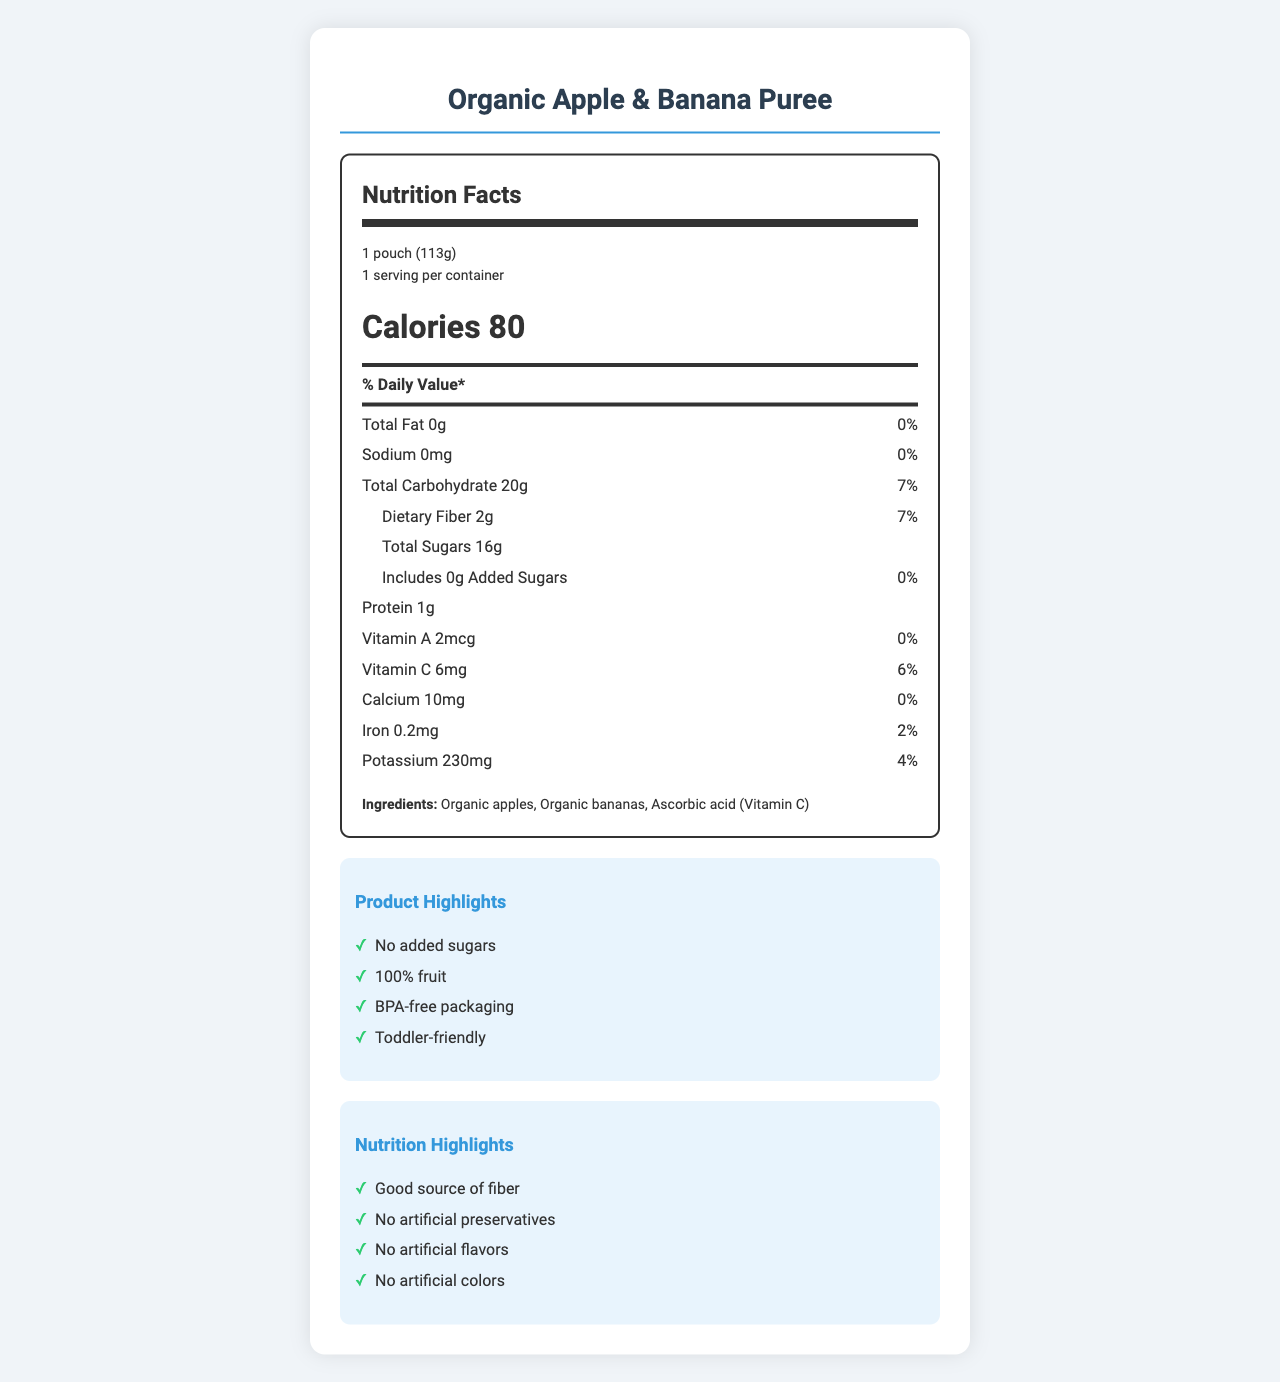what is the serving size? The serving size is clearly mentioned at the beginning of the Nutrition Facts label as 1 pouch (113g).
Answer: 1 pouch (113g) how many servings are in one container? The label specifies that there is 1 serving per container.
Answer: 1 how many calories are in one serving? The Nutrition Facts label lists the calorie count for one serving as 80.
Answer: 80 what is the total amount of fat in the product? The total fat content is listed as 0g on the label.
Answer: 0g how much dietary fiber is in one serving? The label lists 2g of dietary fiber per serving.
Answer: 2g does the product contain any added sugars? The Nutrition Facts label states that the product contains 0g of added sugars.
Answer: No what ingredients are used in this puree? The Ingredients section lists Organic apples, Organic bananas, and Ascorbic acid (Vitamin C).
Answer: Organic apples, Organic bananas, Ascorbic acid (Vitamin C) for what age group is this product suitable? The product's target age is stated as 12+ months.
Answer: 12+ months is the packaging BPA-free? One of the product claims mentions BPA-free packaging.
Answer: Yes which vitamins and minerals are highlighted on the label? A. Vitamin A, Vitamin C, Calcium, Iron, Potassium B. Vitamin B, Vitamin E, Magnesium, Zinc, Sodium C. Vitamin D, Vitamin K, Phosphorus, Copper, Chromium The label lists Vitamin A, Vitamin C, Calcium, Iron, and Potassium.
Answer: A what percentage of the daily value of total carbohydrates does one serving of this product provide? A. 10% B. 5% C. 7% D. 12% The label states that the total carbohydrate content in one serving is 20g, which is 7% of the daily value.
Answer: C does this product contain any tree nuts? The allergen information indicates it is produced in a facility that processes tree nuts but doesn't state that the product contains them.
Answer: No is the pouch recyclable? The document states that the pouch is not recyclable, but the cap is recyclable where facilities exist.
Answer: No summarize the main idea of this document. The document overall presents a comprehensive overview of the "Organic Apple & Banana Puree," focusing on its nutritional benefits, ingredient purity, and suitability for toddlers.
Answer: This document provides detailed nutritional information about the "Organic Apple & Banana Puree" pouch, emphasizing its organic, non-GMO ingredients and lack of additives. It includes nutritional values for various components, ingredient details, product claims, and storage instructions. Can the expiration date be found in the nutrition facts label? The document mentions, "Best if used by: See top of pouch," meaning the specific expiration date is not printed directly within the nutrition facts label itself and must be checked manually.
Answer: No, the expiration date is referenced but the actual date must be checked on the pouch. 